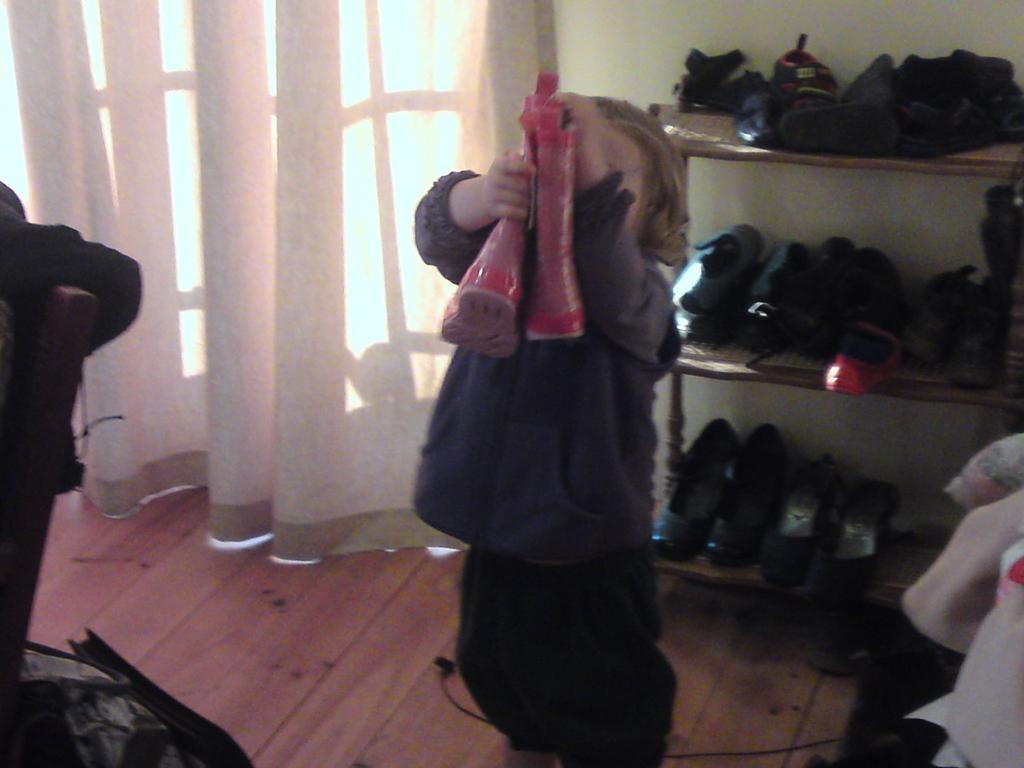In one or two sentences, can you explain what this image depicts? In this image I can see the person is holding the pink color shoes. Back I can see the window, white color curtain, wall, few objects on the floor and few shoes in the rack. 